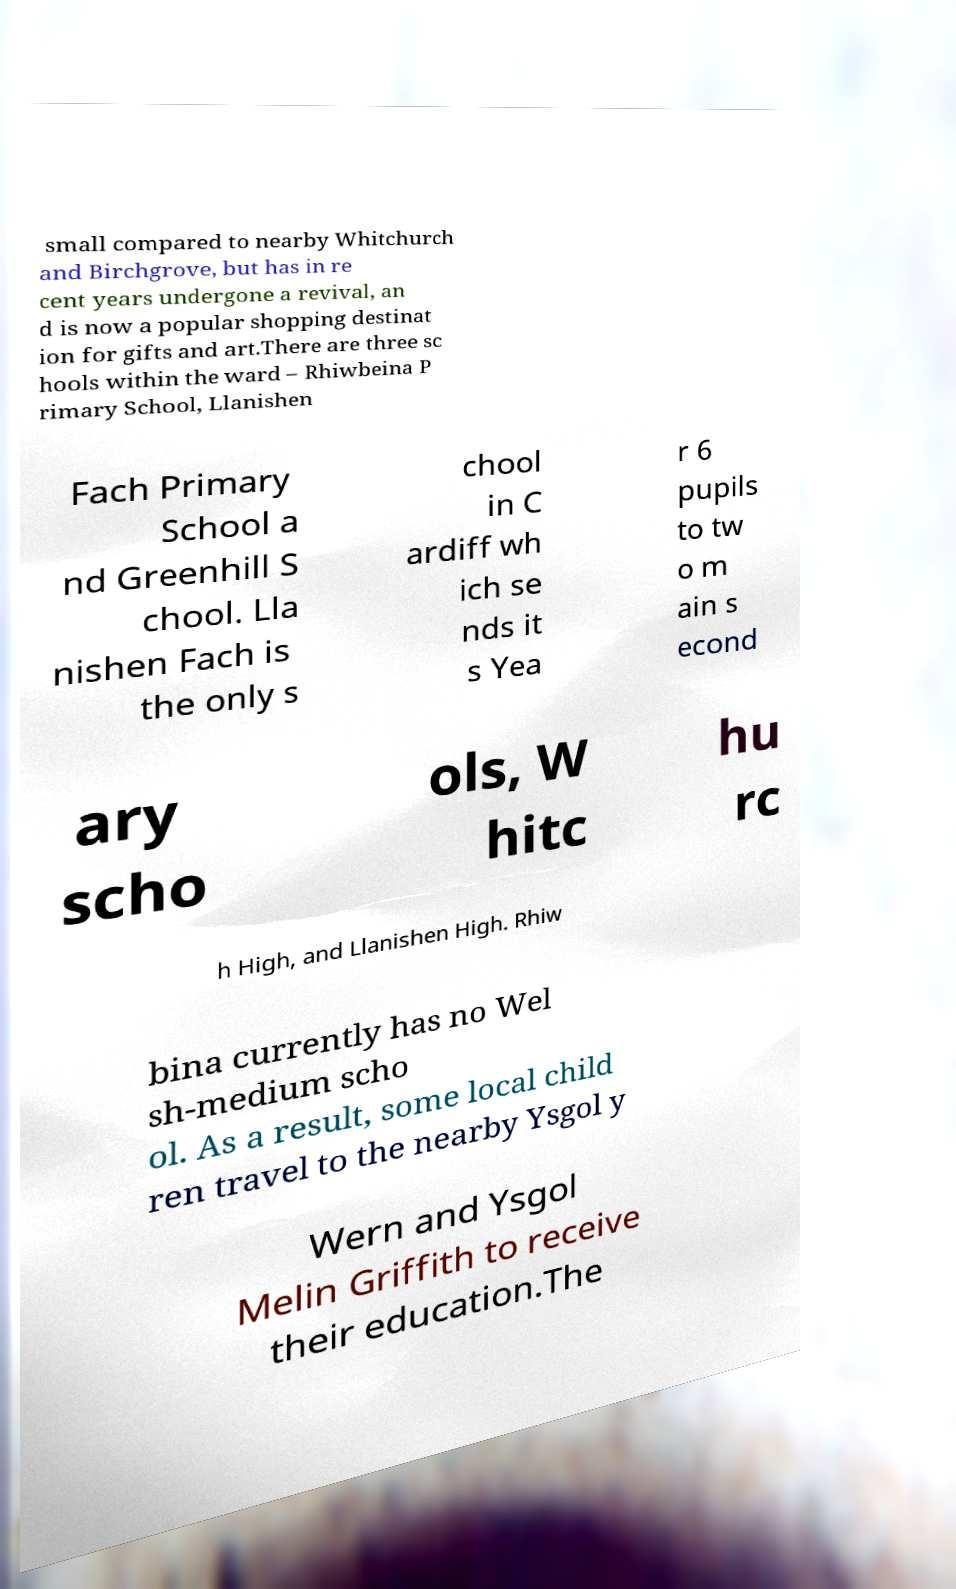Please identify and transcribe the text found in this image. small compared to nearby Whitchurch and Birchgrove, but has in re cent years undergone a revival, an d is now a popular shopping destinat ion for gifts and art.There are three sc hools within the ward – Rhiwbeina P rimary School, Llanishen Fach Primary School a nd Greenhill S chool. Lla nishen Fach is the only s chool in C ardiff wh ich se nds it s Yea r 6 pupils to tw o m ain s econd ary scho ols, W hitc hu rc h High, and Llanishen High. Rhiw bina currently has no Wel sh-medium scho ol. As a result, some local child ren travel to the nearby Ysgol y Wern and Ysgol Melin Griffith to receive their education.The 